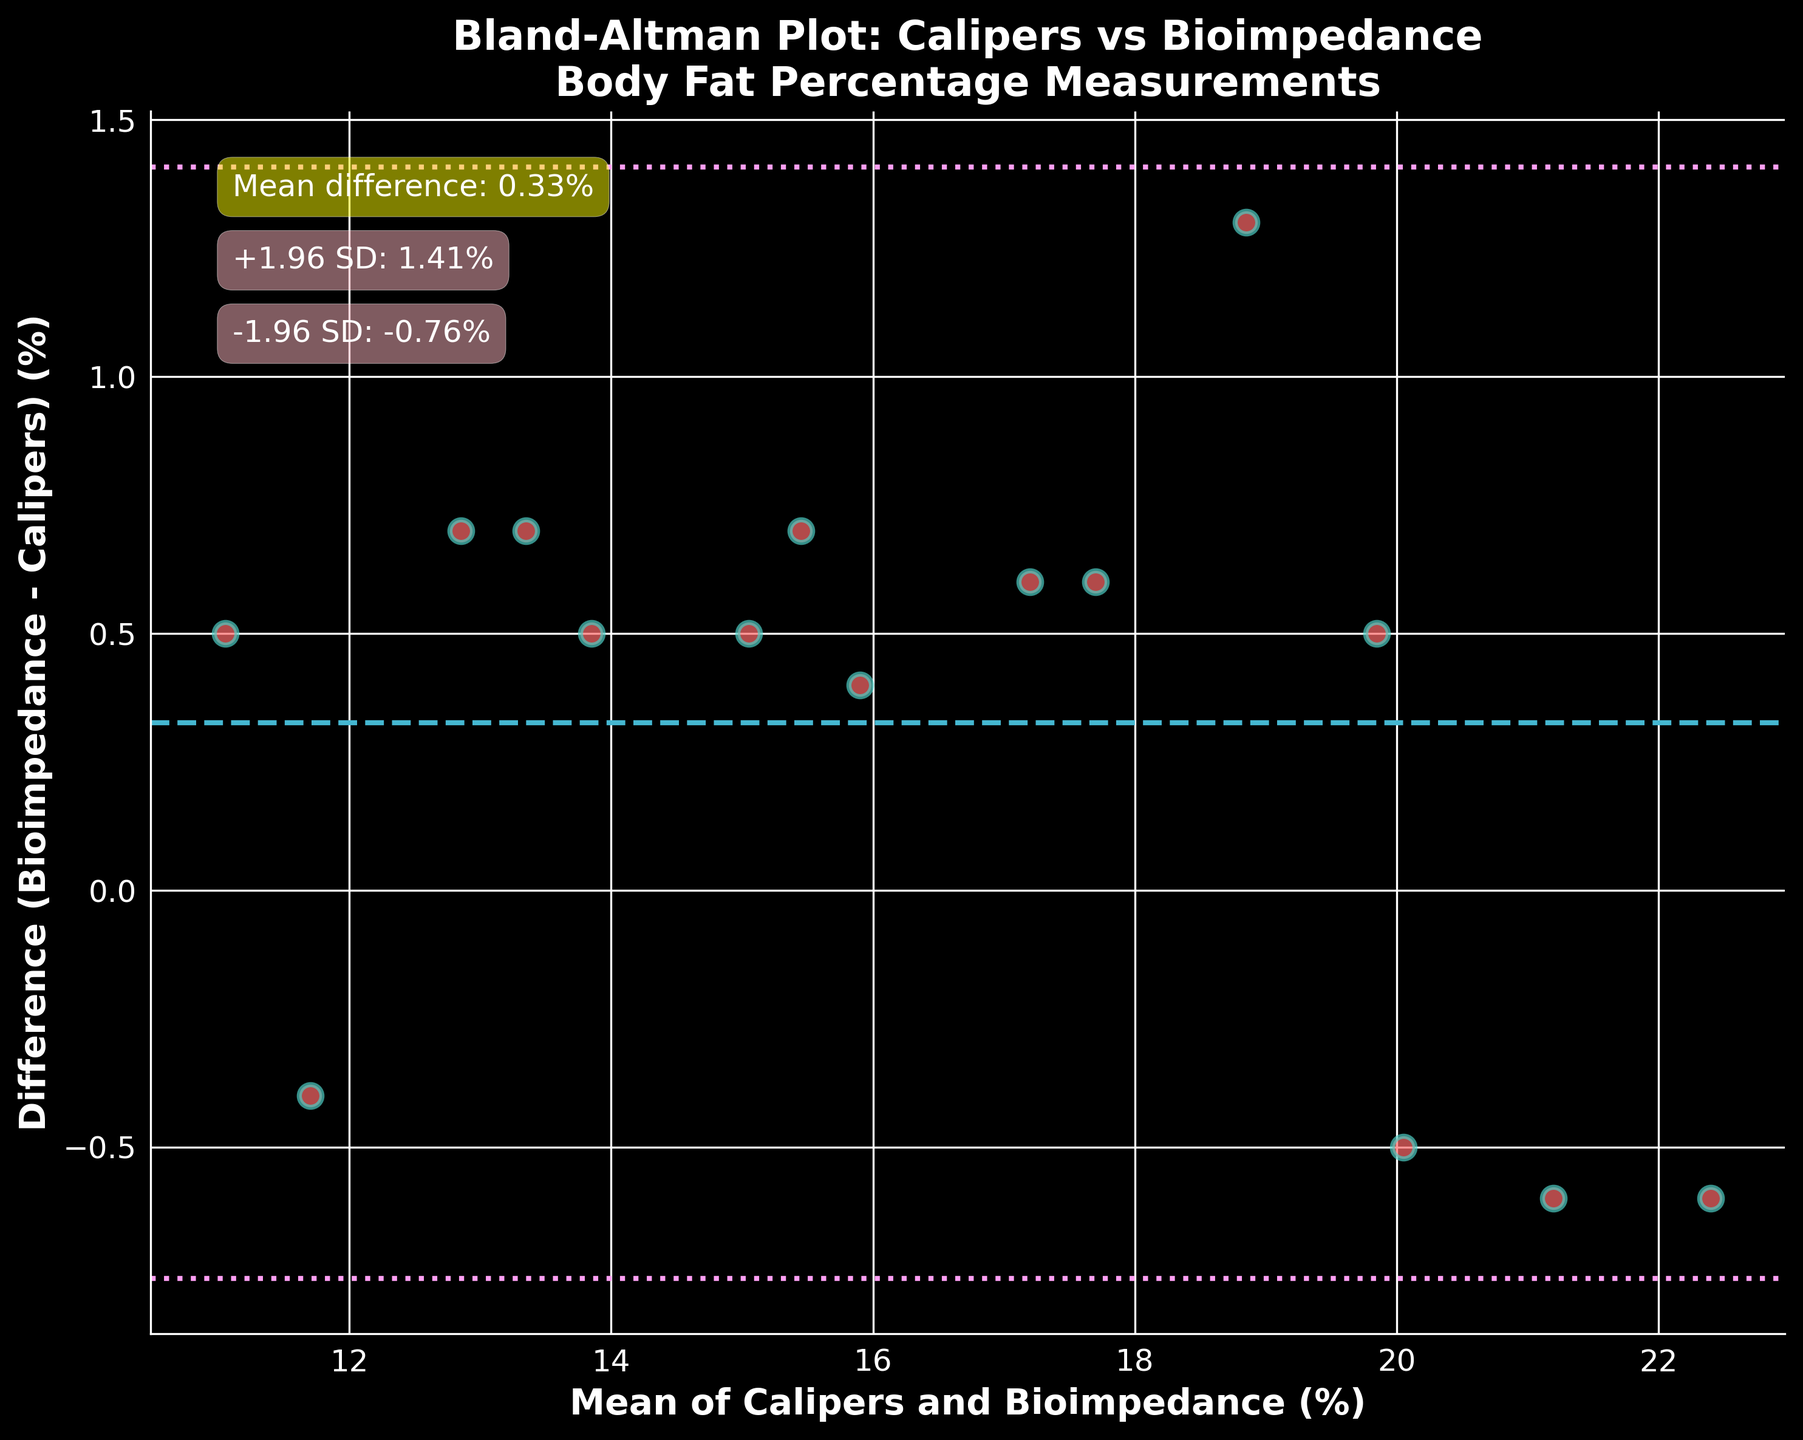What's the title of the plot? The title of the plot is prominently displayed at the top and reads: "Bland-Altman Plot: Calipers vs Bioimpedance\nBody Fat Percentage Measurements".
Answer: Bland-Altman Plot: Calipers vs Bioimpedance\nBody Fat Percentage Measurements What do the dots in the plot represent? The dots represent the individual data points, each indicating the mean and difference of body fat percentage measurements using calipers and bioelectrical impedance for each swimmer.
Answer: Individual data points How many data points are shown in the plot? By counting the individual dots, it's apparent that there are 15 data points shown in the plot.
Answer: 15 What is the mean difference between the measurements by calipers and bioimpedance? The plot includes an annotation that states the mean difference. The annotation says: "Mean difference: 0.32%".
Answer: 0.32% What are the upper and lower limits of agreement? The upper and lower limits of agreement are given by the annotations on the plot. They are "+1.96 SD: 1.48%" and "-1.96 SD: -0.84%".
Answer: 1.48% and -0.84% What's the general trend of the differences between the two measurement techniques? The general trend can be observed by looking at the scatter points; if the points are randomly scattered around the mean difference line with no apparent trend, this shows there's no systematic difference between the two techniques.
Answer: No apparent trend Is there any swimmer whose measurements showed a higher difference than the upper limit of agreement? Observing the plot, none of the data points exceed the upper limit of agreement at 1.48%, as all points are within the defined limits.
Answer: No Is there a clear bias in measurements between the calipers and bioimpedance methods? The mean difference of 0.32% is relatively small, and since the points are scattered roughly evenly around the mean line without a strong directional trend, there isn't a clear bias.
Answer: No clear bias What's the range of the mean body fat percentage measurements shown on the x-axis? The x-axis, which represents the mean of calipers and bioimpedance measurements, ranges roughly from 10% to 23%. This can be estimated by looking at the spread of the data points along the axis.
Answer: 10% to 23% How is the variability indicated in this plot? The variability is indicated by the spread of the data points and the standard deviation lines at +1.96 SD and -1.96 SD around the mean difference line.
Answer: Spread of data points and SD lines 